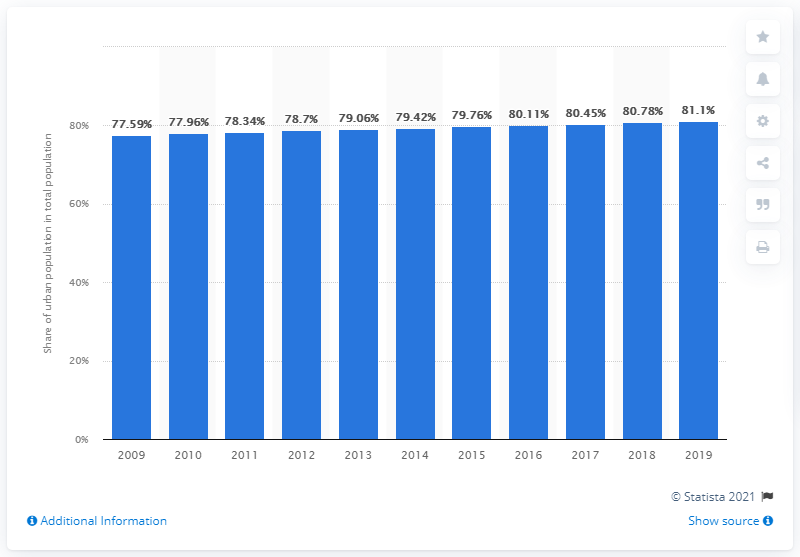Specify some key components in this picture. In 2019, approximately 81.1% of Colombia's population lived in urban areas and cities. 